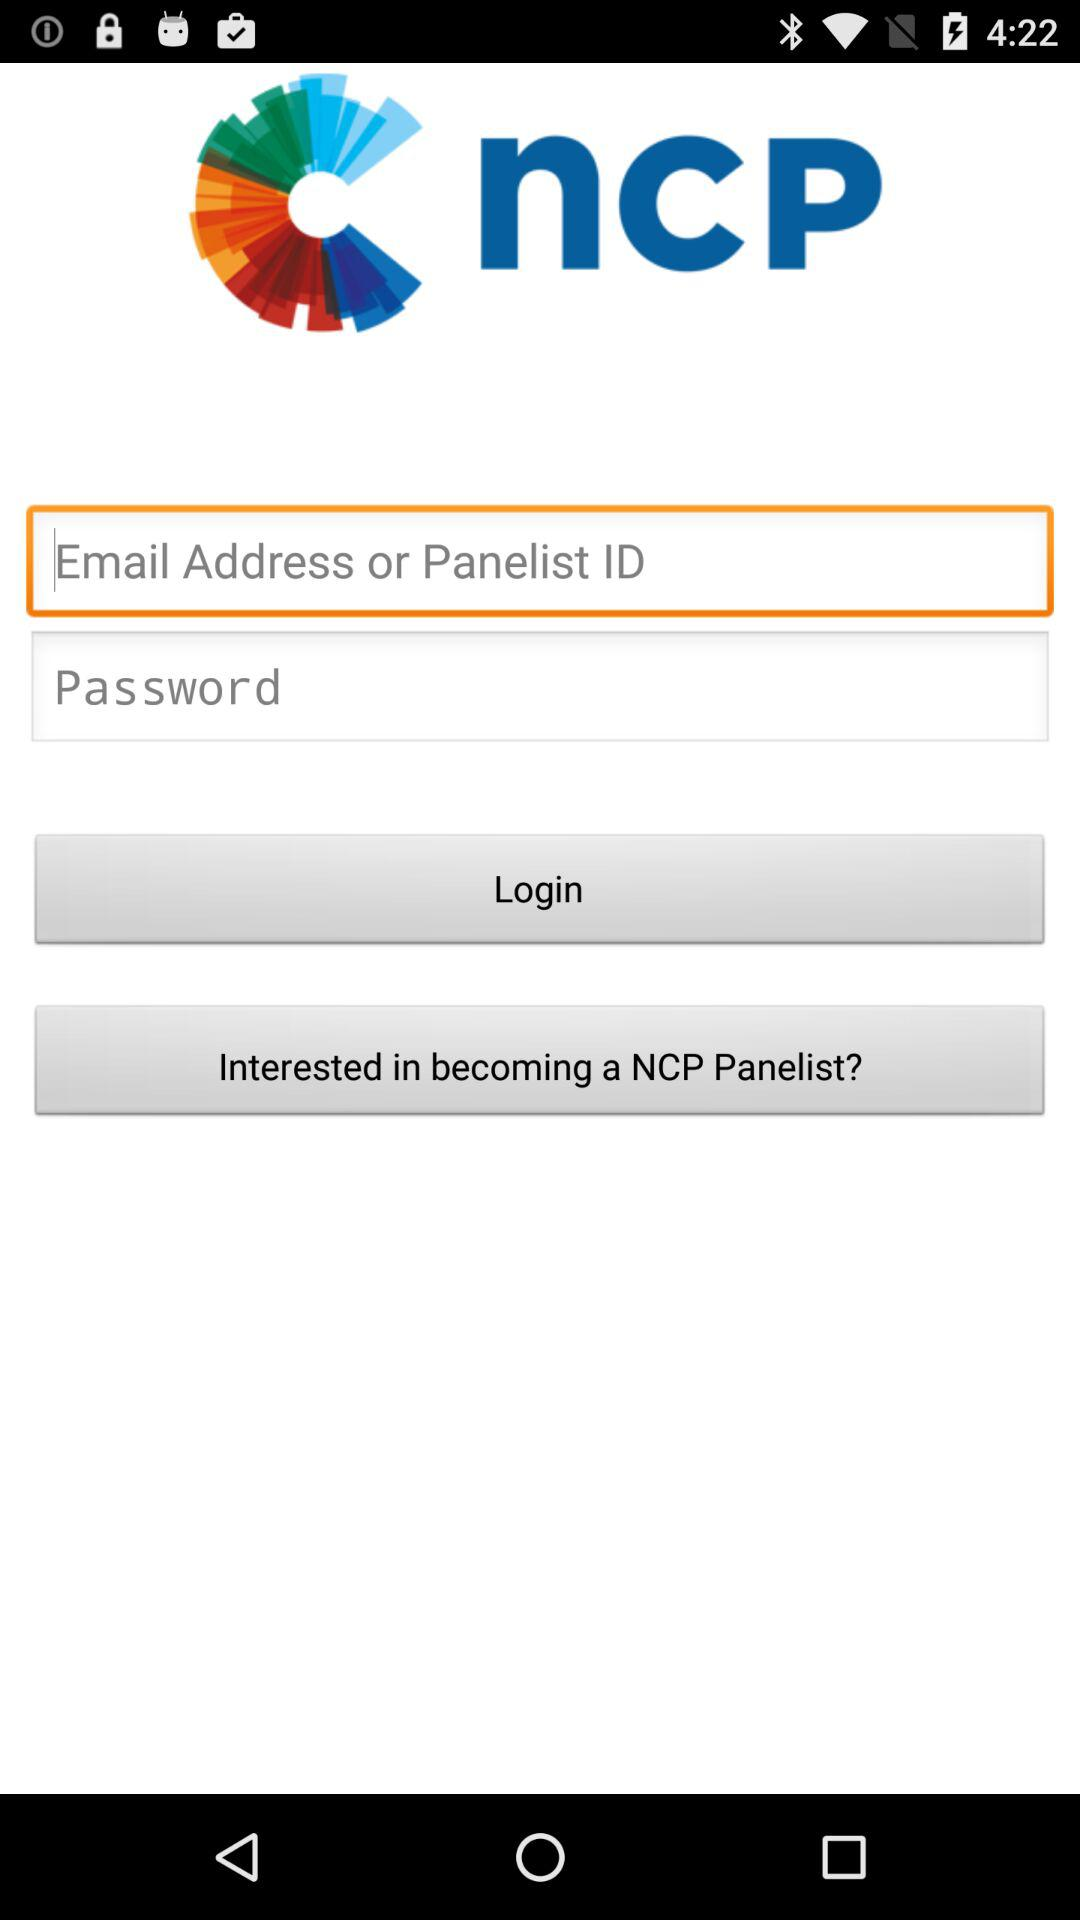How many characters are required to create a password?
When the provided information is insufficient, respond with <no answer>. <no answer> 